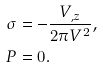<formula> <loc_0><loc_0><loc_500><loc_500>\sigma & = - \frac { V _ { , z } } { 2 \pi V ^ { 2 } } , \\ P & = 0 .</formula> 